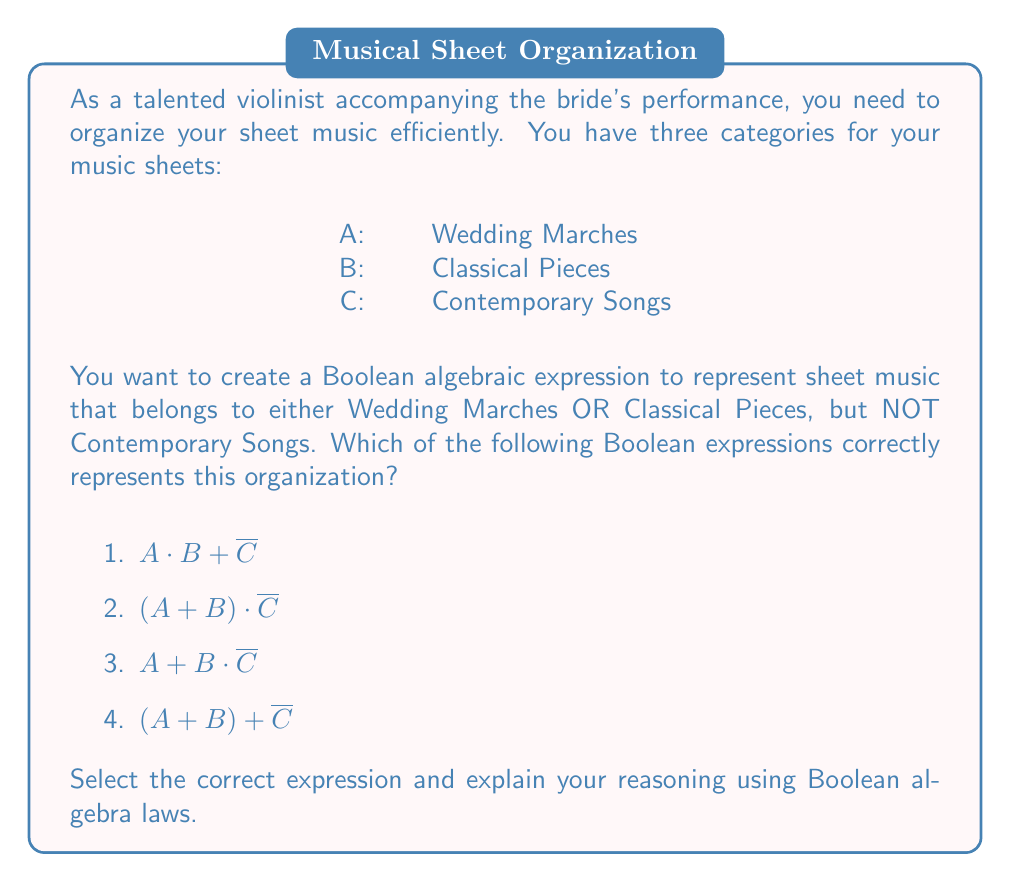Help me with this question. Let's approach this step-by-step:

1) First, let's understand what we're looking for:
   - Sheet music that is either a Wedding March OR a Classical Piece
   - AND NOT a Contemporary Song

2) In Boolean algebra, this translates to:
   $(A \text{ OR } B) \text{ AND (NOT C)}$

3) Using Boolean symbols:
   $(A + B) \cdot \overline{C}$

4) Now, let's evaluate each option:

   1) $A \cdot B + \overline{C}$
      This means (A AND B) OR (NOT C), which is incorrect.

   2) $(A + B) \cdot \overline{C}$
      This correctly represents (A OR B) AND (NOT C).

   3) $A + B \cdot \overline{C}$
      This means A OR (B AND (NOT C)), which is not what we want.

   4) $(A + B) + \overline{C}$
      This means (A OR B) OR (NOT C), which is incorrect.

5) Therefore, option 2 is the correct answer.

6) We can verify this using Boolean algebra laws:
   $$(A + B) \cdot \overline{C} = (A \cdot \overline{C}) + (B \cdot \overline{C})$$

   This expanded form shows that we're including sheet music that is:
   (A Wedding March AND NOT Contemporary) OR (Classical AND NOT Contemporary)

Thus, option 2 correctly organizes the sheet music as required.
Answer: $(A + B) \cdot \overline{C}$ 